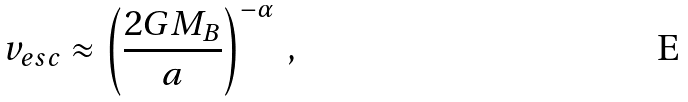Convert formula to latex. <formula><loc_0><loc_0><loc_500><loc_500>v _ { e s c } \approx \left ( \frac { 2 G M _ { B } } { a } \right ) ^ { - \alpha } \, ,</formula> 